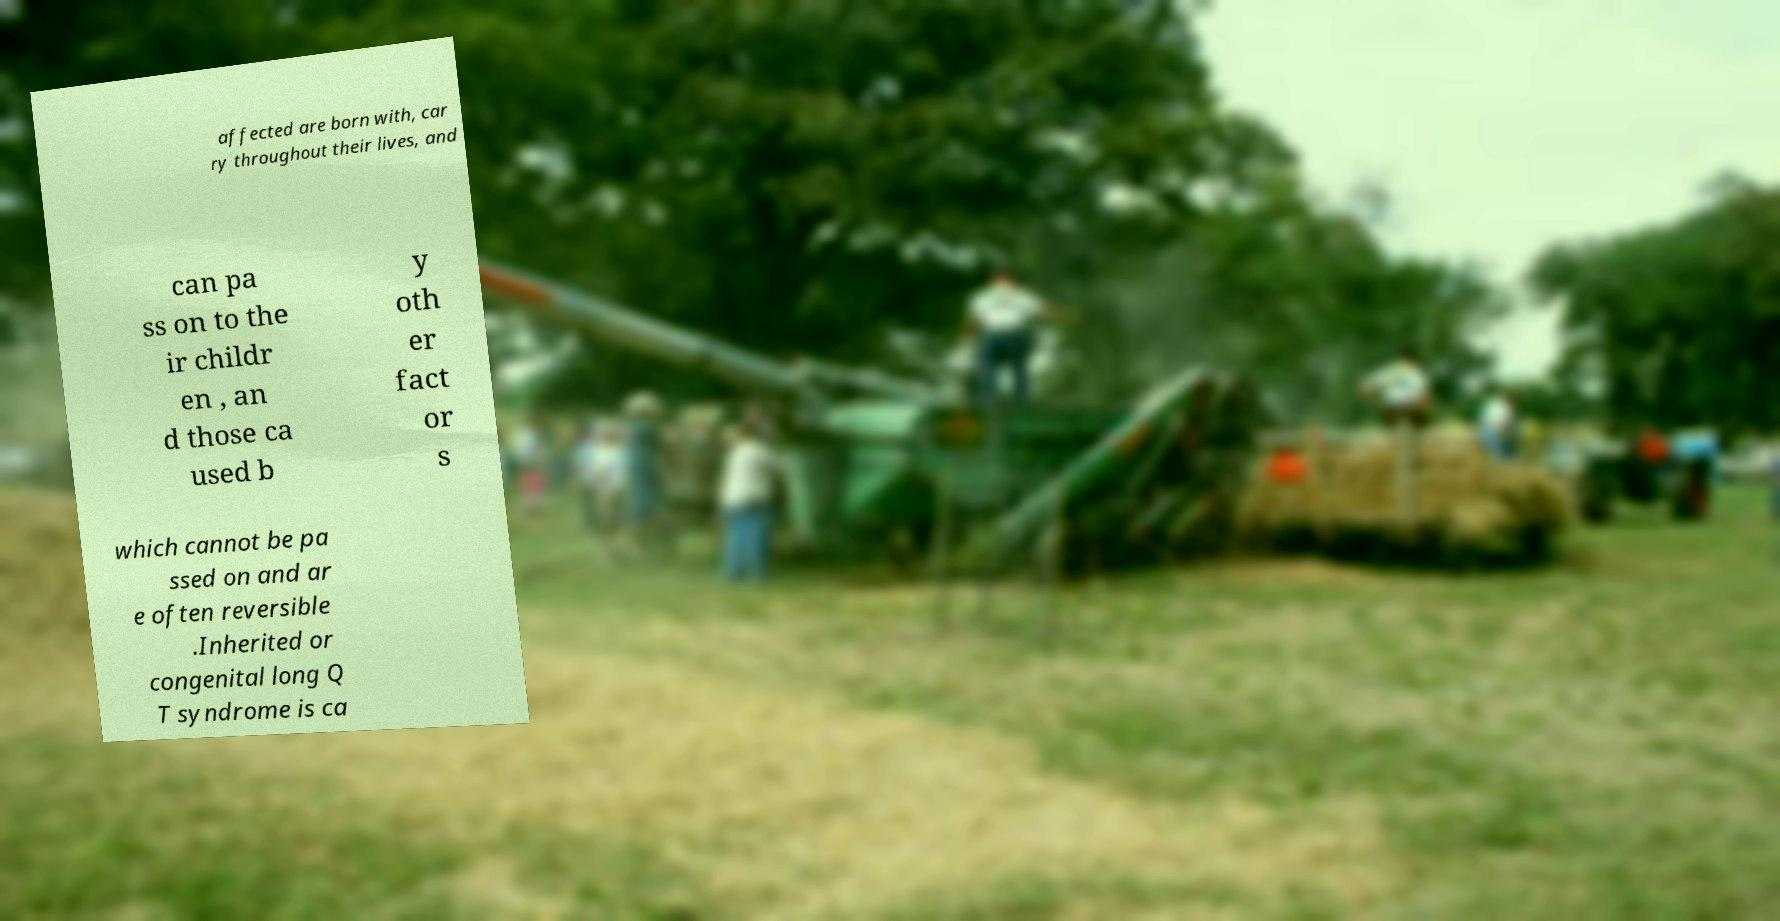Please identify and transcribe the text found in this image. affected are born with, car ry throughout their lives, and can pa ss on to the ir childr en , an d those ca used b y oth er fact or s which cannot be pa ssed on and ar e often reversible .Inherited or congenital long Q T syndrome is ca 